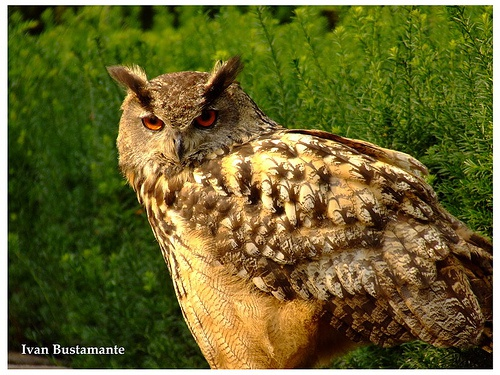Describe the objects in this image and their specific colors. I can see a bird in white, black, maroon, and olive tones in this image. 